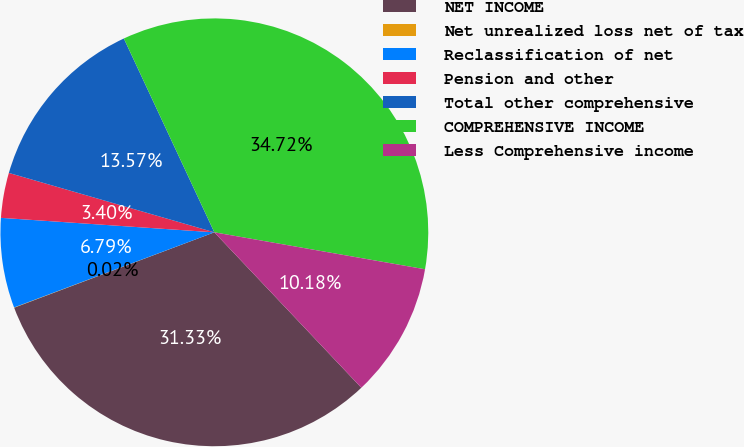<chart> <loc_0><loc_0><loc_500><loc_500><pie_chart><fcel>NET INCOME<fcel>Net unrealized loss net of tax<fcel>Reclassification of net<fcel>Pension and other<fcel>Total other comprehensive<fcel>COMPREHENSIVE INCOME<fcel>Less Comprehensive income<nl><fcel>31.33%<fcel>0.02%<fcel>6.79%<fcel>3.4%<fcel>13.57%<fcel>34.72%<fcel>10.18%<nl></chart> 